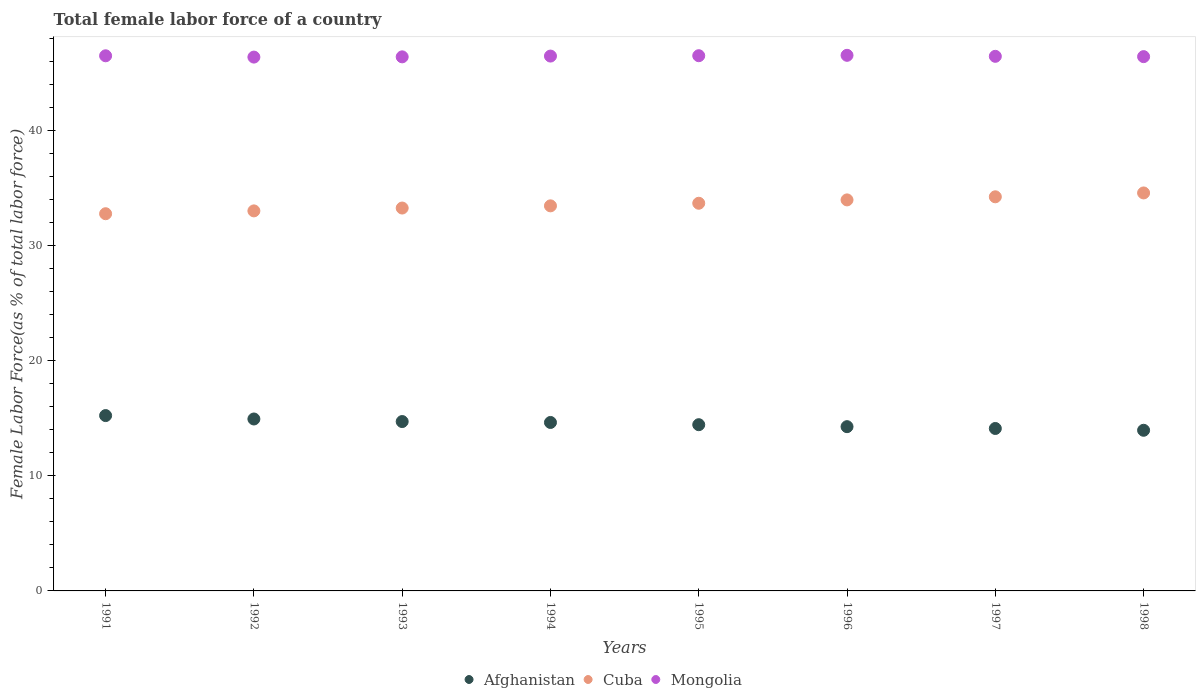How many different coloured dotlines are there?
Make the answer very short. 3. Is the number of dotlines equal to the number of legend labels?
Your response must be concise. Yes. What is the percentage of female labor force in Afghanistan in 1993?
Your response must be concise. 14.71. Across all years, what is the maximum percentage of female labor force in Afghanistan?
Offer a terse response. 15.23. Across all years, what is the minimum percentage of female labor force in Cuba?
Ensure brevity in your answer.  32.76. In which year was the percentage of female labor force in Afghanistan maximum?
Provide a short and direct response. 1991. In which year was the percentage of female labor force in Cuba minimum?
Your response must be concise. 1991. What is the total percentage of female labor force in Afghanistan in the graph?
Provide a short and direct response. 116.26. What is the difference between the percentage of female labor force in Afghanistan in 1993 and that in 1994?
Keep it short and to the point. 0.08. What is the difference between the percentage of female labor force in Mongolia in 1998 and the percentage of female labor force in Cuba in 1995?
Make the answer very short. 12.73. What is the average percentage of female labor force in Cuba per year?
Offer a terse response. 33.61. In the year 1993, what is the difference between the percentage of female labor force in Afghanistan and percentage of female labor force in Cuba?
Keep it short and to the point. -18.54. In how many years, is the percentage of female labor force in Afghanistan greater than 46 %?
Give a very brief answer. 0. What is the ratio of the percentage of female labor force in Cuba in 1993 to that in 1995?
Provide a succinct answer. 0.99. What is the difference between the highest and the second highest percentage of female labor force in Mongolia?
Give a very brief answer. 0.03. What is the difference between the highest and the lowest percentage of female labor force in Cuba?
Keep it short and to the point. 1.81. In how many years, is the percentage of female labor force in Mongolia greater than the average percentage of female labor force in Mongolia taken over all years?
Provide a short and direct response. 4. Is the sum of the percentage of female labor force in Mongolia in 1992 and 1993 greater than the maximum percentage of female labor force in Cuba across all years?
Provide a short and direct response. Yes. Is it the case that in every year, the sum of the percentage of female labor force in Afghanistan and percentage of female labor force in Cuba  is greater than the percentage of female labor force in Mongolia?
Offer a terse response. Yes. Does the percentage of female labor force in Mongolia monotonically increase over the years?
Give a very brief answer. No. Is the percentage of female labor force in Afghanistan strictly greater than the percentage of female labor force in Cuba over the years?
Your answer should be very brief. No. Is the percentage of female labor force in Afghanistan strictly less than the percentage of female labor force in Cuba over the years?
Give a very brief answer. Yes. How many dotlines are there?
Offer a terse response. 3. Are the values on the major ticks of Y-axis written in scientific E-notation?
Keep it short and to the point. No. Does the graph contain any zero values?
Your answer should be compact. No. Where does the legend appear in the graph?
Your answer should be compact. Bottom center. How are the legend labels stacked?
Make the answer very short. Horizontal. What is the title of the graph?
Offer a terse response. Total female labor force of a country. What is the label or title of the Y-axis?
Your response must be concise. Female Labor Force(as % of total labor force). What is the Female Labor Force(as % of total labor force) in Afghanistan in 1991?
Keep it short and to the point. 15.23. What is the Female Labor Force(as % of total labor force) in Cuba in 1991?
Offer a terse response. 32.76. What is the Female Labor Force(as % of total labor force) of Mongolia in 1991?
Provide a short and direct response. 46.47. What is the Female Labor Force(as % of total labor force) in Afghanistan in 1992?
Offer a terse response. 14.93. What is the Female Labor Force(as % of total labor force) in Cuba in 1992?
Ensure brevity in your answer.  33. What is the Female Labor Force(as % of total labor force) in Mongolia in 1992?
Offer a terse response. 46.36. What is the Female Labor Force(as % of total labor force) in Afghanistan in 1993?
Ensure brevity in your answer.  14.71. What is the Female Labor Force(as % of total labor force) of Cuba in 1993?
Ensure brevity in your answer.  33.25. What is the Female Labor Force(as % of total labor force) of Mongolia in 1993?
Your response must be concise. 46.38. What is the Female Labor Force(as % of total labor force) of Afghanistan in 1994?
Provide a succinct answer. 14.63. What is the Female Labor Force(as % of total labor force) of Cuba in 1994?
Your response must be concise. 33.44. What is the Female Labor Force(as % of total labor force) in Mongolia in 1994?
Offer a terse response. 46.45. What is the Female Labor Force(as % of total labor force) of Afghanistan in 1995?
Ensure brevity in your answer.  14.44. What is the Female Labor Force(as % of total labor force) in Cuba in 1995?
Your answer should be very brief. 33.67. What is the Female Labor Force(as % of total labor force) in Mongolia in 1995?
Your answer should be compact. 46.48. What is the Female Labor Force(as % of total labor force) of Afghanistan in 1996?
Your answer should be compact. 14.27. What is the Female Labor Force(as % of total labor force) in Cuba in 1996?
Provide a succinct answer. 33.96. What is the Female Labor Force(as % of total labor force) of Mongolia in 1996?
Ensure brevity in your answer.  46.52. What is the Female Labor Force(as % of total labor force) in Afghanistan in 1997?
Ensure brevity in your answer.  14.11. What is the Female Labor Force(as % of total labor force) in Cuba in 1997?
Your response must be concise. 34.23. What is the Female Labor Force(as % of total labor force) of Mongolia in 1997?
Give a very brief answer. 46.43. What is the Female Labor Force(as % of total labor force) of Afghanistan in 1998?
Provide a succinct answer. 13.95. What is the Female Labor Force(as % of total labor force) in Cuba in 1998?
Your answer should be very brief. 34.56. What is the Female Labor Force(as % of total labor force) of Mongolia in 1998?
Your answer should be compact. 46.4. Across all years, what is the maximum Female Labor Force(as % of total labor force) of Afghanistan?
Keep it short and to the point. 15.23. Across all years, what is the maximum Female Labor Force(as % of total labor force) of Cuba?
Your answer should be very brief. 34.56. Across all years, what is the maximum Female Labor Force(as % of total labor force) of Mongolia?
Ensure brevity in your answer.  46.52. Across all years, what is the minimum Female Labor Force(as % of total labor force) in Afghanistan?
Make the answer very short. 13.95. Across all years, what is the minimum Female Labor Force(as % of total labor force) of Cuba?
Your response must be concise. 32.76. Across all years, what is the minimum Female Labor Force(as % of total labor force) in Mongolia?
Your response must be concise. 46.36. What is the total Female Labor Force(as % of total labor force) in Afghanistan in the graph?
Provide a succinct answer. 116.26. What is the total Female Labor Force(as % of total labor force) of Cuba in the graph?
Ensure brevity in your answer.  268.88. What is the total Female Labor Force(as % of total labor force) in Mongolia in the graph?
Give a very brief answer. 371.49. What is the difference between the Female Labor Force(as % of total labor force) in Afghanistan in 1991 and that in 1992?
Keep it short and to the point. 0.3. What is the difference between the Female Labor Force(as % of total labor force) in Cuba in 1991 and that in 1992?
Ensure brevity in your answer.  -0.25. What is the difference between the Female Labor Force(as % of total labor force) of Mongolia in 1991 and that in 1992?
Offer a very short reply. 0.11. What is the difference between the Female Labor Force(as % of total labor force) in Afghanistan in 1991 and that in 1993?
Provide a succinct answer. 0.52. What is the difference between the Female Labor Force(as % of total labor force) in Cuba in 1991 and that in 1993?
Offer a terse response. -0.49. What is the difference between the Female Labor Force(as % of total labor force) in Mongolia in 1991 and that in 1993?
Your response must be concise. 0.09. What is the difference between the Female Labor Force(as % of total labor force) of Afghanistan in 1991 and that in 1994?
Your response must be concise. 0.6. What is the difference between the Female Labor Force(as % of total labor force) in Cuba in 1991 and that in 1994?
Your answer should be very brief. -0.68. What is the difference between the Female Labor Force(as % of total labor force) in Mongolia in 1991 and that in 1994?
Your answer should be compact. 0.02. What is the difference between the Female Labor Force(as % of total labor force) of Afghanistan in 1991 and that in 1995?
Keep it short and to the point. 0.79. What is the difference between the Female Labor Force(as % of total labor force) of Cuba in 1991 and that in 1995?
Your response must be concise. -0.91. What is the difference between the Female Labor Force(as % of total labor force) of Mongolia in 1991 and that in 1995?
Your answer should be compact. -0.01. What is the difference between the Female Labor Force(as % of total labor force) of Afghanistan in 1991 and that in 1996?
Offer a very short reply. 0.96. What is the difference between the Female Labor Force(as % of total labor force) in Cuba in 1991 and that in 1996?
Your answer should be very brief. -1.2. What is the difference between the Female Labor Force(as % of total labor force) in Mongolia in 1991 and that in 1996?
Your answer should be very brief. -0.04. What is the difference between the Female Labor Force(as % of total labor force) in Afghanistan in 1991 and that in 1997?
Keep it short and to the point. 1.12. What is the difference between the Female Labor Force(as % of total labor force) in Cuba in 1991 and that in 1997?
Make the answer very short. -1.47. What is the difference between the Female Labor Force(as % of total labor force) in Mongolia in 1991 and that in 1997?
Provide a succinct answer. 0.05. What is the difference between the Female Labor Force(as % of total labor force) in Afghanistan in 1991 and that in 1998?
Provide a succinct answer. 1.28. What is the difference between the Female Labor Force(as % of total labor force) in Cuba in 1991 and that in 1998?
Your response must be concise. -1.81. What is the difference between the Female Labor Force(as % of total labor force) of Mongolia in 1991 and that in 1998?
Provide a short and direct response. 0.07. What is the difference between the Female Labor Force(as % of total labor force) in Afghanistan in 1992 and that in 1993?
Your answer should be very brief. 0.22. What is the difference between the Female Labor Force(as % of total labor force) of Cuba in 1992 and that in 1993?
Offer a very short reply. -0.25. What is the difference between the Female Labor Force(as % of total labor force) in Mongolia in 1992 and that in 1993?
Offer a terse response. -0.02. What is the difference between the Female Labor Force(as % of total labor force) of Afghanistan in 1992 and that in 1994?
Offer a terse response. 0.3. What is the difference between the Female Labor Force(as % of total labor force) in Cuba in 1992 and that in 1994?
Your response must be concise. -0.44. What is the difference between the Female Labor Force(as % of total labor force) of Mongolia in 1992 and that in 1994?
Make the answer very short. -0.09. What is the difference between the Female Labor Force(as % of total labor force) of Afghanistan in 1992 and that in 1995?
Your answer should be very brief. 0.5. What is the difference between the Female Labor Force(as % of total labor force) in Cuba in 1992 and that in 1995?
Ensure brevity in your answer.  -0.66. What is the difference between the Female Labor Force(as % of total labor force) in Mongolia in 1992 and that in 1995?
Give a very brief answer. -0.12. What is the difference between the Female Labor Force(as % of total labor force) in Afghanistan in 1992 and that in 1996?
Ensure brevity in your answer.  0.67. What is the difference between the Female Labor Force(as % of total labor force) of Cuba in 1992 and that in 1996?
Provide a succinct answer. -0.95. What is the difference between the Female Labor Force(as % of total labor force) in Mongolia in 1992 and that in 1996?
Offer a very short reply. -0.15. What is the difference between the Female Labor Force(as % of total labor force) of Afghanistan in 1992 and that in 1997?
Offer a terse response. 0.82. What is the difference between the Female Labor Force(as % of total labor force) of Cuba in 1992 and that in 1997?
Make the answer very short. -1.22. What is the difference between the Female Labor Force(as % of total labor force) of Mongolia in 1992 and that in 1997?
Your response must be concise. -0.07. What is the difference between the Female Labor Force(as % of total labor force) of Afghanistan in 1992 and that in 1998?
Offer a terse response. 0.98. What is the difference between the Female Labor Force(as % of total labor force) in Cuba in 1992 and that in 1998?
Offer a terse response. -1.56. What is the difference between the Female Labor Force(as % of total labor force) of Mongolia in 1992 and that in 1998?
Offer a terse response. -0.04. What is the difference between the Female Labor Force(as % of total labor force) of Afghanistan in 1993 and that in 1994?
Offer a very short reply. 0.08. What is the difference between the Female Labor Force(as % of total labor force) of Cuba in 1993 and that in 1994?
Offer a terse response. -0.19. What is the difference between the Female Labor Force(as % of total labor force) of Mongolia in 1993 and that in 1994?
Give a very brief answer. -0.07. What is the difference between the Female Labor Force(as % of total labor force) in Afghanistan in 1993 and that in 1995?
Provide a short and direct response. 0.27. What is the difference between the Female Labor Force(as % of total labor force) in Cuba in 1993 and that in 1995?
Ensure brevity in your answer.  -0.42. What is the difference between the Female Labor Force(as % of total labor force) in Mongolia in 1993 and that in 1995?
Offer a very short reply. -0.1. What is the difference between the Female Labor Force(as % of total labor force) in Afghanistan in 1993 and that in 1996?
Keep it short and to the point. 0.44. What is the difference between the Female Labor Force(as % of total labor force) in Cuba in 1993 and that in 1996?
Make the answer very short. -0.71. What is the difference between the Female Labor Force(as % of total labor force) in Mongolia in 1993 and that in 1996?
Make the answer very short. -0.13. What is the difference between the Female Labor Force(as % of total labor force) in Afghanistan in 1993 and that in 1997?
Offer a terse response. 0.6. What is the difference between the Female Labor Force(as % of total labor force) of Cuba in 1993 and that in 1997?
Offer a very short reply. -0.98. What is the difference between the Female Labor Force(as % of total labor force) of Mongolia in 1993 and that in 1997?
Keep it short and to the point. -0.05. What is the difference between the Female Labor Force(as % of total labor force) of Afghanistan in 1993 and that in 1998?
Give a very brief answer. 0.76. What is the difference between the Female Labor Force(as % of total labor force) of Cuba in 1993 and that in 1998?
Ensure brevity in your answer.  -1.31. What is the difference between the Female Labor Force(as % of total labor force) in Mongolia in 1993 and that in 1998?
Your answer should be compact. -0.02. What is the difference between the Female Labor Force(as % of total labor force) of Afghanistan in 1994 and that in 1995?
Give a very brief answer. 0.19. What is the difference between the Female Labor Force(as % of total labor force) in Cuba in 1994 and that in 1995?
Provide a succinct answer. -0.23. What is the difference between the Female Labor Force(as % of total labor force) of Mongolia in 1994 and that in 1995?
Provide a succinct answer. -0.03. What is the difference between the Female Labor Force(as % of total labor force) of Afghanistan in 1994 and that in 1996?
Offer a very short reply. 0.36. What is the difference between the Female Labor Force(as % of total labor force) in Cuba in 1994 and that in 1996?
Provide a short and direct response. -0.52. What is the difference between the Female Labor Force(as % of total labor force) in Mongolia in 1994 and that in 1996?
Give a very brief answer. -0.07. What is the difference between the Female Labor Force(as % of total labor force) of Afghanistan in 1994 and that in 1997?
Keep it short and to the point. 0.52. What is the difference between the Female Labor Force(as % of total labor force) of Cuba in 1994 and that in 1997?
Provide a succinct answer. -0.79. What is the difference between the Female Labor Force(as % of total labor force) of Mongolia in 1994 and that in 1997?
Offer a very short reply. 0.02. What is the difference between the Female Labor Force(as % of total labor force) in Afghanistan in 1994 and that in 1998?
Provide a short and direct response. 0.68. What is the difference between the Female Labor Force(as % of total labor force) of Cuba in 1994 and that in 1998?
Your answer should be very brief. -1.12. What is the difference between the Female Labor Force(as % of total labor force) of Mongolia in 1994 and that in 1998?
Ensure brevity in your answer.  0.05. What is the difference between the Female Labor Force(as % of total labor force) of Afghanistan in 1995 and that in 1996?
Provide a succinct answer. 0.17. What is the difference between the Female Labor Force(as % of total labor force) in Cuba in 1995 and that in 1996?
Keep it short and to the point. -0.29. What is the difference between the Female Labor Force(as % of total labor force) in Mongolia in 1995 and that in 1996?
Offer a very short reply. -0.03. What is the difference between the Female Labor Force(as % of total labor force) in Afghanistan in 1995 and that in 1997?
Offer a very short reply. 0.33. What is the difference between the Female Labor Force(as % of total labor force) of Cuba in 1995 and that in 1997?
Give a very brief answer. -0.56. What is the difference between the Female Labor Force(as % of total labor force) of Mongolia in 1995 and that in 1997?
Your answer should be very brief. 0.05. What is the difference between the Female Labor Force(as % of total labor force) in Afghanistan in 1995 and that in 1998?
Keep it short and to the point. 0.48. What is the difference between the Female Labor Force(as % of total labor force) in Cuba in 1995 and that in 1998?
Make the answer very short. -0.9. What is the difference between the Female Labor Force(as % of total labor force) of Mongolia in 1995 and that in 1998?
Offer a very short reply. 0.08. What is the difference between the Female Labor Force(as % of total labor force) of Afghanistan in 1996 and that in 1997?
Your answer should be very brief. 0.16. What is the difference between the Female Labor Force(as % of total labor force) of Cuba in 1996 and that in 1997?
Your answer should be very brief. -0.27. What is the difference between the Female Labor Force(as % of total labor force) in Mongolia in 1996 and that in 1997?
Your response must be concise. 0.09. What is the difference between the Female Labor Force(as % of total labor force) of Afghanistan in 1996 and that in 1998?
Your answer should be very brief. 0.31. What is the difference between the Female Labor Force(as % of total labor force) in Cuba in 1996 and that in 1998?
Give a very brief answer. -0.6. What is the difference between the Female Labor Force(as % of total labor force) in Mongolia in 1996 and that in 1998?
Your answer should be compact. 0.11. What is the difference between the Female Labor Force(as % of total labor force) in Afghanistan in 1997 and that in 1998?
Your response must be concise. 0.16. What is the difference between the Female Labor Force(as % of total labor force) in Cuba in 1997 and that in 1998?
Ensure brevity in your answer.  -0.34. What is the difference between the Female Labor Force(as % of total labor force) of Mongolia in 1997 and that in 1998?
Provide a short and direct response. 0.03. What is the difference between the Female Labor Force(as % of total labor force) of Afghanistan in 1991 and the Female Labor Force(as % of total labor force) of Cuba in 1992?
Your response must be concise. -17.78. What is the difference between the Female Labor Force(as % of total labor force) in Afghanistan in 1991 and the Female Labor Force(as % of total labor force) in Mongolia in 1992?
Your answer should be compact. -31.13. What is the difference between the Female Labor Force(as % of total labor force) of Cuba in 1991 and the Female Labor Force(as % of total labor force) of Mongolia in 1992?
Give a very brief answer. -13.6. What is the difference between the Female Labor Force(as % of total labor force) of Afghanistan in 1991 and the Female Labor Force(as % of total labor force) of Cuba in 1993?
Give a very brief answer. -18.02. What is the difference between the Female Labor Force(as % of total labor force) in Afghanistan in 1991 and the Female Labor Force(as % of total labor force) in Mongolia in 1993?
Provide a succinct answer. -31.15. What is the difference between the Female Labor Force(as % of total labor force) of Cuba in 1991 and the Female Labor Force(as % of total labor force) of Mongolia in 1993?
Your answer should be compact. -13.62. What is the difference between the Female Labor Force(as % of total labor force) in Afghanistan in 1991 and the Female Labor Force(as % of total labor force) in Cuba in 1994?
Provide a short and direct response. -18.21. What is the difference between the Female Labor Force(as % of total labor force) in Afghanistan in 1991 and the Female Labor Force(as % of total labor force) in Mongolia in 1994?
Your answer should be very brief. -31.22. What is the difference between the Female Labor Force(as % of total labor force) in Cuba in 1991 and the Female Labor Force(as % of total labor force) in Mongolia in 1994?
Provide a short and direct response. -13.69. What is the difference between the Female Labor Force(as % of total labor force) in Afghanistan in 1991 and the Female Labor Force(as % of total labor force) in Cuba in 1995?
Give a very brief answer. -18.44. What is the difference between the Female Labor Force(as % of total labor force) of Afghanistan in 1991 and the Female Labor Force(as % of total labor force) of Mongolia in 1995?
Offer a terse response. -31.25. What is the difference between the Female Labor Force(as % of total labor force) of Cuba in 1991 and the Female Labor Force(as % of total labor force) of Mongolia in 1995?
Give a very brief answer. -13.72. What is the difference between the Female Labor Force(as % of total labor force) of Afghanistan in 1991 and the Female Labor Force(as % of total labor force) of Cuba in 1996?
Your response must be concise. -18.73. What is the difference between the Female Labor Force(as % of total labor force) in Afghanistan in 1991 and the Female Labor Force(as % of total labor force) in Mongolia in 1996?
Give a very brief answer. -31.29. What is the difference between the Female Labor Force(as % of total labor force) of Cuba in 1991 and the Female Labor Force(as % of total labor force) of Mongolia in 1996?
Provide a succinct answer. -13.76. What is the difference between the Female Labor Force(as % of total labor force) of Afghanistan in 1991 and the Female Labor Force(as % of total labor force) of Cuba in 1997?
Provide a succinct answer. -19. What is the difference between the Female Labor Force(as % of total labor force) in Afghanistan in 1991 and the Female Labor Force(as % of total labor force) in Mongolia in 1997?
Provide a short and direct response. -31.2. What is the difference between the Female Labor Force(as % of total labor force) in Cuba in 1991 and the Female Labor Force(as % of total labor force) in Mongolia in 1997?
Ensure brevity in your answer.  -13.67. What is the difference between the Female Labor Force(as % of total labor force) of Afghanistan in 1991 and the Female Labor Force(as % of total labor force) of Cuba in 1998?
Give a very brief answer. -19.34. What is the difference between the Female Labor Force(as % of total labor force) in Afghanistan in 1991 and the Female Labor Force(as % of total labor force) in Mongolia in 1998?
Give a very brief answer. -31.17. What is the difference between the Female Labor Force(as % of total labor force) of Cuba in 1991 and the Female Labor Force(as % of total labor force) of Mongolia in 1998?
Provide a succinct answer. -13.64. What is the difference between the Female Labor Force(as % of total labor force) of Afghanistan in 1992 and the Female Labor Force(as % of total labor force) of Cuba in 1993?
Your answer should be compact. -18.32. What is the difference between the Female Labor Force(as % of total labor force) of Afghanistan in 1992 and the Female Labor Force(as % of total labor force) of Mongolia in 1993?
Ensure brevity in your answer.  -31.45. What is the difference between the Female Labor Force(as % of total labor force) in Cuba in 1992 and the Female Labor Force(as % of total labor force) in Mongolia in 1993?
Keep it short and to the point. -13.38. What is the difference between the Female Labor Force(as % of total labor force) of Afghanistan in 1992 and the Female Labor Force(as % of total labor force) of Cuba in 1994?
Offer a terse response. -18.51. What is the difference between the Female Labor Force(as % of total labor force) of Afghanistan in 1992 and the Female Labor Force(as % of total labor force) of Mongolia in 1994?
Offer a terse response. -31.52. What is the difference between the Female Labor Force(as % of total labor force) in Cuba in 1992 and the Female Labor Force(as % of total labor force) in Mongolia in 1994?
Ensure brevity in your answer.  -13.44. What is the difference between the Female Labor Force(as % of total labor force) of Afghanistan in 1992 and the Female Labor Force(as % of total labor force) of Cuba in 1995?
Keep it short and to the point. -18.74. What is the difference between the Female Labor Force(as % of total labor force) of Afghanistan in 1992 and the Female Labor Force(as % of total labor force) of Mongolia in 1995?
Offer a very short reply. -31.55. What is the difference between the Female Labor Force(as % of total labor force) in Cuba in 1992 and the Female Labor Force(as % of total labor force) in Mongolia in 1995?
Offer a very short reply. -13.48. What is the difference between the Female Labor Force(as % of total labor force) in Afghanistan in 1992 and the Female Labor Force(as % of total labor force) in Cuba in 1996?
Your answer should be compact. -19.03. What is the difference between the Female Labor Force(as % of total labor force) of Afghanistan in 1992 and the Female Labor Force(as % of total labor force) of Mongolia in 1996?
Provide a succinct answer. -31.58. What is the difference between the Female Labor Force(as % of total labor force) in Cuba in 1992 and the Female Labor Force(as % of total labor force) in Mongolia in 1996?
Provide a short and direct response. -13.51. What is the difference between the Female Labor Force(as % of total labor force) in Afghanistan in 1992 and the Female Labor Force(as % of total labor force) in Cuba in 1997?
Offer a terse response. -19.3. What is the difference between the Female Labor Force(as % of total labor force) in Afghanistan in 1992 and the Female Labor Force(as % of total labor force) in Mongolia in 1997?
Give a very brief answer. -31.5. What is the difference between the Female Labor Force(as % of total labor force) in Cuba in 1992 and the Female Labor Force(as % of total labor force) in Mongolia in 1997?
Make the answer very short. -13.42. What is the difference between the Female Labor Force(as % of total labor force) in Afghanistan in 1992 and the Female Labor Force(as % of total labor force) in Cuba in 1998?
Offer a very short reply. -19.63. What is the difference between the Female Labor Force(as % of total labor force) of Afghanistan in 1992 and the Female Labor Force(as % of total labor force) of Mongolia in 1998?
Offer a terse response. -31.47. What is the difference between the Female Labor Force(as % of total labor force) in Cuba in 1992 and the Female Labor Force(as % of total labor force) in Mongolia in 1998?
Offer a very short reply. -13.4. What is the difference between the Female Labor Force(as % of total labor force) in Afghanistan in 1993 and the Female Labor Force(as % of total labor force) in Cuba in 1994?
Offer a terse response. -18.73. What is the difference between the Female Labor Force(as % of total labor force) of Afghanistan in 1993 and the Female Labor Force(as % of total labor force) of Mongolia in 1994?
Your answer should be compact. -31.74. What is the difference between the Female Labor Force(as % of total labor force) of Cuba in 1993 and the Female Labor Force(as % of total labor force) of Mongolia in 1994?
Offer a terse response. -13.2. What is the difference between the Female Labor Force(as % of total labor force) of Afghanistan in 1993 and the Female Labor Force(as % of total labor force) of Cuba in 1995?
Make the answer very short. -18.96. What is the difference between the Female Labor Force(as % of total labor force) in Afghanistan in 1993 and the Female Labor Force(as % of total labor force) in Mongolia in 1995?
Offer a terse response. -31.77. What is the difference between the Female Labor Force(as % of total labor force) of Cuba in 1993 and the Female Labor Force(as % of total labor force) of Mongolia in 1995?
Make the answer very short. -13.23. What is the difference between the Female Labor Force(as % of total labor force) of Afghanistan in 1993 and the Female Labor Force(as % of total labor force) of Cuba in 1996?
Your response must be concise. -19.25. What is the difference between the Female Labor Force(as % of total labor force) in Afghanistan in 1993 and the Female Labor Force(as % of total labor force) in Mongolia in 1996?
Offer a very short reply. -31.81. What is the difference between the Female Labor Force(as % of total labor force) of Cuba in 1993 and the Female Labor Force(as % of total labor force) of Mongolia in 1996?
Make the answer very short. -13.26. What is the difference between the Female Labor Force(as % of total labor force) in Afghanistan in 1993 and the Female Labor Force(as % of total labor force) in Cuba in 1997?
Provide a short and direct response. -19.52. What is the difference between the Female Labor Force(as % of total labor force) of Afghanistan in 1993 and the Female Labor Force(as % of total labor force) of Mongolia in 1997?
Your response must be concise. -31.72. What is the difference between the Female Labor Force(as % of total labor force) in Cuba in 1993 and the Female Labor Force(as % of total labor force) in Mongolia in 1997?
Your answer should be compact. -13.18. What is the difference between the Female Labor Force(as % of total labor force) in Afghanistan in 1993 and the Female Labor Force(as % of total labor force) in Cuba in 1998?
Your response must be concise. -19.85. What is the difference between the Female Labor Force(as % of total labor force) of Afghanistan in 1993 and the Female Labor Force(as % of total labor force) of Mongolia in 1998?
Your answer should be very brief. -31.69. What is the difference between the Female Labor Force(as % of total labor force) in Cuba in 1993 and the Female Labor Force(as % of total labor force) in Mongolia in 1998?
Ensure brevity in your answer.  -13.15. What is the difference between the Female Labor Force(as % of total labor force) in Afghanistan in 1994 and the Female Labor Force(as % of total labor force) in Cuba in 1995?
Offer a terse response. -19.04. What is the difference between the Female Labor Force(as % of total labor force) of Afghanistan in 1994 and the Female Labor Force(as % of total labor force) of Mongolia in 1995?
Keep it short and to the point. -31.85. What is the difference between the Female Labor Force(as % of total labor force) in Cuba in 1994 and the Female Labor Force(as % of total labor force) in Mongolia in 1995?
Your response must be concise. -13.04. What is the difference between the Female Labor Force(as % of total labor force) of Afghanistan in 1994 and the Female Labor Force(as % of total labor force) of Cuba in 1996?
Provide a succinct answer. -19.33. What is the difference between the Female Labor Force(as % of total labor force) of Afghanistan in 1994 and the Female Labor Force(as % of total labor force) of Mongolia in 1996?
Your answer should be compact. -31.89. What is the difference between the Female Labor Force(as % of total labor force) of Cuba in 1994 and the Female Labor Force(as % of total labor force) of Mongolia in 1996?
Your answer should be compact. -13.07. What is the difference between the Female Labor Force(as % of total labor force) in Afghanistan in 1994 and the Female Labor Force(as % of total labor force) in Cuba in 1997?
Provide a short and direct response. -19.6. What is the difference between the Female Labor Force(as % of total labor force) in Afghanistan in 1994 and the Female Labor Force(as % of total labor force) in Mongolia in 1997?
Offer a terse response. -31.8. What is the difference between the Female Labor Force(as % of total labor force) of Cuba in 1994 and the Female Labor Force(as % of total labor force) of Mongolia in 1997?
Offer a terse response. -12.99. What is the difference between the Female Labor Force(as % of total labor force) in Afghanistan in 1994 and the Female Labor Force(as % of total labor force) in Cuba in 1998?
Ensure brevity in your answer.  -19.93. What is the difference between the Female Labor Force(as % of total labor force) in Afghanistan in 1994 and the Female Labor Force(as % of total labor force) in Mongolia in 1998?
Give a very brief answer. -31.77. What is the difference between the Female Labor Force(as % of total labor force) of Cuba in 1994 and the Female Labor Force(as % of total labor force) of Mongolia in 1998?
Offer a very short reply. -12.96. What is the difference between the Female Labor Force(as % of total labor force) of Afghanistan in 1995 and the Female Labor Force(as % of total labor force) of Cuba in 1996?
Offer a very short reply. -19.52. What is the difference between the Female Labor Force(as % of total labor force) of Afghanistan in 1995 and the Female Labor Force(as % of total labor force) of Mongolia in 1996?
Provide a succinct answer. -32.08. What is the difference between the Female Labor Force(as % of total labor force) of Cuba in 1995 and the Female Labor Force(as % of total labor force) of Mongolia in 1996?
Your response must be concise. -12.85. What is the difference between the Female Labor Force(as % of total labor force) in Afghanistan in 1995 and the Female Labor Force(as % of total labor force) in Cuba in 1997?
Your response must be concise. -19.79. What is the difference between the Female Labor Force(as % of total labor force) of Afghanistan in 1995 and the Female Labor Force(as % of total labor force) of Mongolia in 1997?
Offer a very short reply. -31.99. What is the difference between the Female Labor Force(as % of total labor force) in Cuba in 1995 and the Female Labor Force(as % of total labor force) in Mongolia in 1997?
Your answer should be compact. -12.76. What is the difference between the Female Labor Force(as % of total labor force) of Afghanistan in 1995 and the Female Labor Force(as % of total labor force) of Cuba in 1998?
Give a very brief answer. -20.13. What is the difference between the Female Labor Force(as % of total labor force) in Afghanistan in 1995 and the Female Labor Force(as % of total labor force) in Mongolia in 1998?
Ensure brevity in your answer.  -31.96. What is the difference between the Female Labor Force(as % of total labor force) of Cuba in 1995 and the Female Labor Force(as % of total labor force) of Mongolia in 1998?
Give a very brief answer. -12.73. What is the difference between the Female Labor Force(as % of total labor force) of Afghanistan in 1996 and the Female Labor Force(as % of total labor force) of Cuba in 1997?
Your answer should be very brief. -19.96. What is the difference between the Female Labor Force(as % of total labor force) of Afghanistan in 1996 and the Female Labor Force(as % of total labor force) of Mongolia in 1997?
Give a very brief answer. -32.16. What is the difference between the Female Labor Force(as % of total labor force) in Cuba in 1996 and the Female Labor Force(as % of total labor force) in Mongolia in 1997?
Offer a terse response. -12.47. What is the difference between the Female Labor Force(as % of total labor force) of Afghanistan in 1996 and the Female Labor Force(as % of total labor force) of Cuba in 1998?
Make the answer very short. -20.3. What is the difference between the Female Labor Force(as % of total labor force) in Afghanistan in 1996 and the Female Labor Force(as % of total labor force) in Mongolia in 1998?
Offer a very short reply. -32.14. What is the difference between the Female Labor Force(as % of total labor force) of Cuba in 1996 and the Female Labor Force(as % of total labor force) of Mongolia in 1998?
Ensure brevity in your answer.  -12.44. What is the difference between the Female Labor Force(as % of total labor force) in Afghanistan in 1997 and the Female Labor Force(as % of total labor force) in Cuba in 1998?
Your answer should be very brief. -20.46. What is the difference between the Female Labor Force(as % of total labor force) in Afghanistan in 1997 and the Female Labor Force(as % of total labor force) in Mongolia in 1998?
Provide a succinct answer. -32.29. What is the difference between the Female Labor Force(as % of total labor force) in Cuba in 1997 and the Female Labor Force(as % of total labor force) in Mongolia in 1998?
Offer a terse response. -12.17. What is the average Female Labor Force(as % of total labor force) of Afghanistan per year?
Your response must be concise. 14.53. What is the average Female Labor Force(as % of total labor force) of Cuba per year?
Your answer should be very brief. 33.61. What is the average Female Labor Force(as % of total labor force) of Mongolia per year?
Your answer should be very brief. 46.44. In the year 1991, what is the difference between the Female Labor Force(as % of total labor force) of Afghanistan and Female Labor Force(as % of total labor force) of Cuba?
Your response must be concise. -17.53. In the year 1991, what is the difference between the Female Labor Force(as % of total labor force) of Afghanistan and Female Labor Force(as % of total labor force) of Mongolia?
Your response must be concise. -31.25. In the year 1991, what is the difference between the Female Labor Force(as % of total labor force) in Cuba and Female Labor Force(as % of total labor force) in Mongolia?
Give a very brief answer. -13.72. In the year 1992, what is the difference between the Female Labor Force(as % of total labor force) in Afghanistan and Female Labor Force(as % of total labor force) in Cuba?
Give a very brief answer. -18.07. In the year 1992, what is the difference between the Female Labor Force(as % of total labor force) of Afghanistan and Female Labor Force(as % of total labor force) of Mongolia?
Provide a succinct answer. -31.43. In the year 1992, what is the difference between the Female Labor Force(as % of total labor force) of Cuba and Female Labor Force(as % of total labor force) of Mongolia?
Your answer should be compact. -13.36. In the year 1993, what is the difference between the Female Labor Force(as % of total labor force) in Afghanistan and Female Labor Force(as % of total labor force) in Cuba?
Give a very brief answer. -18.54. In the year 1993, what is the difference between the Female Labor Force(as % of total labor force) in Afghanistan and Female Labor Force(as % of total labor force) in Mongolia?
Offer a very short reply. -31.67. In the year 1993, what is the difference between the Female Labor Force(as % of total labor force) in Cuba and Female Labor Force(as % of total labor force) in Mongolia?
Make the answer very short. -13.13. In the year 1994, what is the difference between the Female Labor Force(as % of total labor force) in Afghanistan and Female Labor Force(as % of total labor force) in Cuba?
Your answer should be compact. -18.81. In the year 1994, what is the difference between the Female Labor Force(as % of total labor force) in Afghanistan and Female Labor Force(as % of total labor force) in Mongolia?
Provide a short and direct response. -31.82. In the year 1994, what is the difference between the Female Labor Force(as % of total labor force) in Cuba and Female Labor Force(as % of total labor force) in Mongolia?
Offer a very short reply. -13.01. In the year 1995, what is the difference between the Female Labor Force(as % of total labor force) of Afghanistan and Female Labor Force(as % of total labor force) of Cuba?
Offer a very short reply. -19.23. In the year 1995, what is the difference between the Female Labor Force(as % of total labor force) in Afghanistan and Female Labor Force(as % of total labor force) in Mongolia?
Offer a very short reply. -32.05. In the year 1995, what is the difference between the Female Labor Force(as % of total labor force) of Cuba and Female Labor Force(as % of total labor force) of Mongolia?
Your answer should be compact. -12.81. In the year 1996, what is the difference between the Female Labor Force(as % of total labor force) of Afghanistan and Female Labor Force(as % of total labor force) of Cuba?
Provide a succinct answer. -19.69. In the year 1996, what is the difference between the Female Labor Force(as % of total labor force) in Afghanistan and Female Labor Force(as % of total labor force) in Mongolia?
Keep it short and to the point. -32.25. In the year 1996, what is the difference between the Female Labor Force(as % of total labor force) of Cuba and Female Labor Force(as % of total labor force) of Mongolia?
Make the answer very short. -12.56. In the year 1997, what is the difference between the Female Labor Force(as % of total labor force) of Afghanistan and Female Labor Force(as % of total labor force) of Cuba?
Your answer should be compact. -20.12. In the year 1997, what is the difference between the Female Labor Force(as % of total labor force) in Afghanistan and Female Labor Force(as % of total labor force) in Mongolia?
Make the answer very short. -32.32. In the year 1997, what is the difference between the Female Labor Force(as % of total labor force) of Cuba and Female Labor Force(as % of total labor force) of Mongolia?
Offer a terse response. -12.2. In the year 1998, what is the difference between the Female Labor Force(as % of total labor force) in Afghanistan and Female Labor Force(as % of total labor force) in Cuba?
Your answer should be compact. -20.61. In the year 1998, what is the difference between the Female Labor Force(as % of total labor force) in Afghanistan and Female Labor Force(as % of total labor force) in Mongolia?
Give a very brief answer. -32.45. In the year 1998, what is the difference between the Female Labor Force(as % of total labor force) of Cuba and Female Labor Force(as % of total labor force) of Mongolia?
Provide a short and direct response. -11.84. What is the ratio of the Female Labor Force(as % of total labor force) in Afghanistan in 1991 to that in 1992?
Offer a very short reply. 1.02. What is the ratio of the Female Labor Force(as % of total labor force) of Mongolia in 1991 to that in 1992?
Provide a short and direct response. 1. What is the ratio of the Female Labor Force(as % of total labor force) of Afghanistan in 1991 to that in 1993?
Ensure brevity in your answer.  1.04. What is the ratio of the Female Labor Force(as % of total labor force) of Cuba in 1991 to that in 1993?
Offer a very short reply. 0.99. What is the ratio of the Female Labor Force(as % of total labor force) in Afghanistan in 1991 to that in 1994?
Provide a succinct answer. 1.04. What is the ratio of the Female Labor Force(as % of total labor force) in Cuba in 1991 to that in 1994?
Your answer should be compact. 0.98. What is the ratio of the Female Labor Force(as % of total labor force) in Mongolia in 1991 to that in 1994?
Provide a succinct answer. 1. What is the ratio of the Female Labor Force(as % of total labor force) of Afghanistan in 1991 to that in 1995?
Give a very brief answer. 1.05. What is the ratio of the Female Labor Force(as % of total labor force) in Cuba in 1991 to that in 1995?
Your response must be concise. 0.97. What is the ratio of the Female Labor Force(as % of total labor force) of Mongolia in 1991 to that in 1995?
Provide a short and direct response. 1. What is the ratio of the Female Labor Force(as % of total labor force) in Afghanistan in 1991 to that in 1996?
Give a very brief answer. 1.07. What is the ratio of the Female Labor Force(as % of total labor force) in Cuba in 1991 to that in 1996?
Offer a very short reply. 0.96. What is the ratio of the Female Labor Force(as % of total labor force) of Mongolia in 1991 to that in 1996?
Provide a short and direct response. 1. What is the ratio of the Female Labor Force(as % of total labor force) of Afghanistan in 1991 to that in 1997?
Ensure brevity in your answer.  1.08. What is the ratio of the Female Labor Force(as % of total labor force) of Cuba in 1991 to that in 1997?
Your answer should be compact. 0.96. What is the ratio of the Female Labor Force(as % of total labor force) in Mongolia in 1991 to that in 1997?
Keep it short and to the point. 1. What is the ratio of the Female Labor Force(as % of total labor force) of Afghanistan in 1991 to that in 1998?
Offer a very short reply. 1.09. What is the ratio of the Female Labor Force(as % of total labor force) of Cuba in 1991 to that in 1998?
Your answer should be compact. 0.95. What is the ratio of the Female Labor Force(as % of total labor force) in Mongolia in 1991 to that in 1998?
Provide a short and direct response. 1. What is the ratio of the Female Labor Force(as % of total labor force) of Afghanistan in 1992 to that in 1993?
Give a very brief answer. 1.02. What is the ratio of the Female Labor Force(as % of total labor force) in Afghanistan in 1992 to that in 1994?
Give a very brief answer. 1.02. What is the ratio of the Female Labor Force(as % of total labor force) of Cuba in 1992 to that in 1994?
Your answer should be compact. 0.99. What is the ratio of the Female Labor Force(as % of total labor force) of Mongolia in 1992 to that in 1994?
Your answer should be compact. 1. What is the ratio of the Female Labor Force(as % of total labor force) of Afghanistan in 1992 to that in 1995?
Offer a very short reply. 1.03. What is the ratio of the Female Labor Force(as % of total labor force) in Cuba in 1992 to that in 1995?
Your answer should be compact. 0.98. What is the ratio of the Female Labor Force(as % of total labor force) in Mongolia in 1992 to that in 1995?
Keep it short and to the point. 1. What is the ratio of the Female Labor Force(as % of total labor force) in Afghanistan in 1992 to that in 1996?
Provide a short and direct response. 1.05. What is the ratio of the Female Labor Force(as % of total labor force) of Cuba in 1992 to that in 1996?
Offer a terse response. 0.97. What is the ratio of the Female Labor Force(as % of total labor force) of Afghanistan in 1992 to that in 1997?
Your response must be concise. 1.06. What is the ratio of the Female Labor Force(as % of total labor force) of Afghanistan in 1992 to that in 1998?
Offer a terse response. 1.07. What is the ratio of the Female Labor Force(as % of total labor force) of Cuba in 1992 to that in 1998?
Your response must be concise. 0.95. What is the ratio of the Female Labor Force(as % of total labor force) in Mongolia in 1992 to that in 1998?
Keep it short and to the point. 1. What is the ratio of the Female Labor Force(as % of total labor force) of Afghanistan in 1993 to that in 1994?
Keep it short and to the point. 1.01. What is the ratio of the Female Labor Force(as % of total labor force) of Cuba in 1993 to that in 1994?
Offer a very short reply. 0.99. What is the ratio of the Female Labor Force(as % of total labor force) of Mongolia in 1993 to that in 1994?
Provide a succinct answer. 1. What is the ratio of the Female Labor Force(as % of total labor force) of Afghanistan in 1993 to that in 1995?
Keep it short and to the point. 1.02. What is the ratio of the Female Labor Force(as % of total labor force) in Cuba in 1993 to that in 1995?
Give a very brief answer. 0.99. What is the ratio of the Female Labor Force(as % of total labor force) in Mongolia in 1993 to that in 1995?
Give a very brief answer. 1. What is the ratio of the Female Labor Force(as % of total labor force) of Afghanistan in 1993 to that in 1996?
Your response must be concise. 1.03. What is the ratio of the Female Labor Force(as % of total labor force) of Cuba in 1993 to that in 1996?
Your response must be concise. 0.98. What is the ratio of the Female Labor Force(as % of total labor force) of Afghanistan in 1993 to that in 1997?
Your answer should be very brief. 1.04. What is the ratio of the Female Labor Force(as % of total labor force) of Cuba in 1993 to that in 1997?
Give a very brief answer. 0.97. What is the ratio of the Female Labor Force(as % of total labor force) in Mongolia in 1993 to that in 1997?
Provide a short and direct response. 1. What is the ratio of the Female Labor Force(as % of total labor force) in Afghanistan in 1993 to that in 1998?
Give a very brief answer. 1.05. What is the ratio of the Female Labor Force(as % of total labor force) in Cuba in 1993 to that in 1998?
Keep it short and to the point. 0.96. What is the ratio of the Female Labor Force(as % of total labor force) in Mongolia in 1993 to that in 1998?
Offer a terse response. 1. What is the ratio of the Female Labor Force(as % of total labor force) in Afghanistan in 1994 to that in 1995?
Keep it short and to the point. 1.01. What is the ratio of the Female Labor Force(as % of total labor force) in Cuba in 1994 to that in 1995?
Your answer should be very brief. 0.99. What is the ratio of the Female Labor Force(as % of total labor force) in Afghanistan in 1994 to that in 1996?
Provide a succinct answer. 1.03. What is the ratio of the Female Labor Force(as % of total labor force) in Cuba in 1994 to that in 1996?
Provide a short and direct response. 0.98. What is the ratio of the Female Labor Force(as % of total labor force) of Afghanistan in 1994 to that in 1997?
Offer a terse response. 1.04. What is the ratio of the Female Labor Force(as % of total labor force) in Afghanistan in 1994 to that in 1998?
Offer a very short reply. 1.05. What is the ratio of the Female Labor Force(as % of total labor force) in Cuba in 1994 to that in 1998?
Your response must be concise. 0.97. What is the ratio of the Female Labor Force(as % of total labor force) of Mongolia in 1994 to that in 1998?
Ensure brevity in your answer.  1. What is the ratio of the Female Labor Force(as % of total labor force) in Mongolia in 1995 to that in 1996?
Keep it short and to the point. 1. What is the ratio of the Female Labor Force(as % of total labor force) in Afghanistan in 1995 to that in 1997?
Your response must be concise. 1.02. What is the ratio of the Female Labor Force(as % of total labor force) in Cuba in 1995 to that in 1997?
Give a very brief answer. 0.98. What is the ratio of the Female Labor Force(as % of total labor force) in Mongolia in 1995 to that in 1997?
Give a very brief answer. 1. What is the ratio of the Female Labor Force(as % of total labor force) in Afghanistan in 1995 to that in 1998?
Your answer should be compact. 1.03. What is the ratio of the Female Labor Force(as % of total labor force) of Cuba in 1995 to that in 1998?
Keep it short and to the point. 0.97. What is the ratio of the Female Labor Force(as % of total labor force) of Mongolia in 1995 to that in 1998?
Give a very brief answer. 1. What is the ratio of the Female Labor Force(as % of total labor force) in Afghanistan in 1996 to that in 1997?
Make the answer very short. 1.01. What is the ratio of the Female Labor Force(as % of total labor force) of Cuba in 1996 to that in 1997?
Make the answer very short. 0.99. What is the ratio of the Female Labor Force(as % of total labor force) of Mongolia in 1996 to that in 1997?
Provide a short and direct response. 1. What is the ratio of the Female Labor Force(as % of total labor force) of Afghanistan in 1996 to that in 1998?
Provide a succinct answer. 1.02. What is the ratio of the Female Labor Force(as % of total labor force) of Cuba in 1996 to that in 1998?
Your answer should be very brief. 0.98. What is the ratio of the Female Labor Force(as % of total labor force) in Afghanistan in 1997 to that in 1998?
Provide a succinct answer. 1.01. What is the ratio of the Female Labor Force(as % of total labor force) of Cuba in 1997 to that in 1998?
Offer a terse response. 0.99. What is the difference between the highest and the second highest Female Labor Force(as % of total labor force) in Afghanistan?
Your answer should be very brief. 0.3. What is the difference between the highest and the second highest Female Labor Force(as % of total labor force) of Cuba?
Provide a succinct answer. 0.34. What is the difference between the highest and the second highest Female Labor Force(as % of total labor force) in Mongolia?
Ensure brevity in your answer.  0.03. What is the difference between the highest and the lowest Female Labor Force(as % of total labor force) in Afghanistan?
Your response must be concise. 1.28. What is the difference between the highest and the lowest Female Labor Force(as % of total labor force) of Cuba?
Provide a succinct answer. 1.81. What is the difference between the highest and the lowest Female Labor Force(as % of total labor force) in Mongolia?
Ensure brevity in your answer.  0.15. 